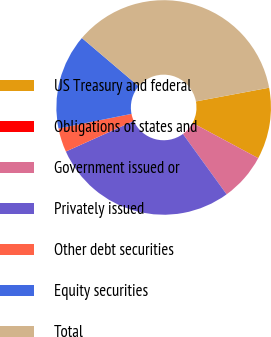Convert chart. <chart><loc_0><loc_0><loc_500><loc_500><pie_chart><fcel>US Treasury and federal<fcel>Obligations of states and<fcel>Government issued or<fcel>Privately issued<fcel>Other debt securities<fcel>Equity securities<fcel>Total<nl><fcel>10.77%<fcel>0.02%<fcel>7.18%<fcel>28.24%<fcel>3.6%<fcel>14.35%<fcel>35.85%<nl></chart> 